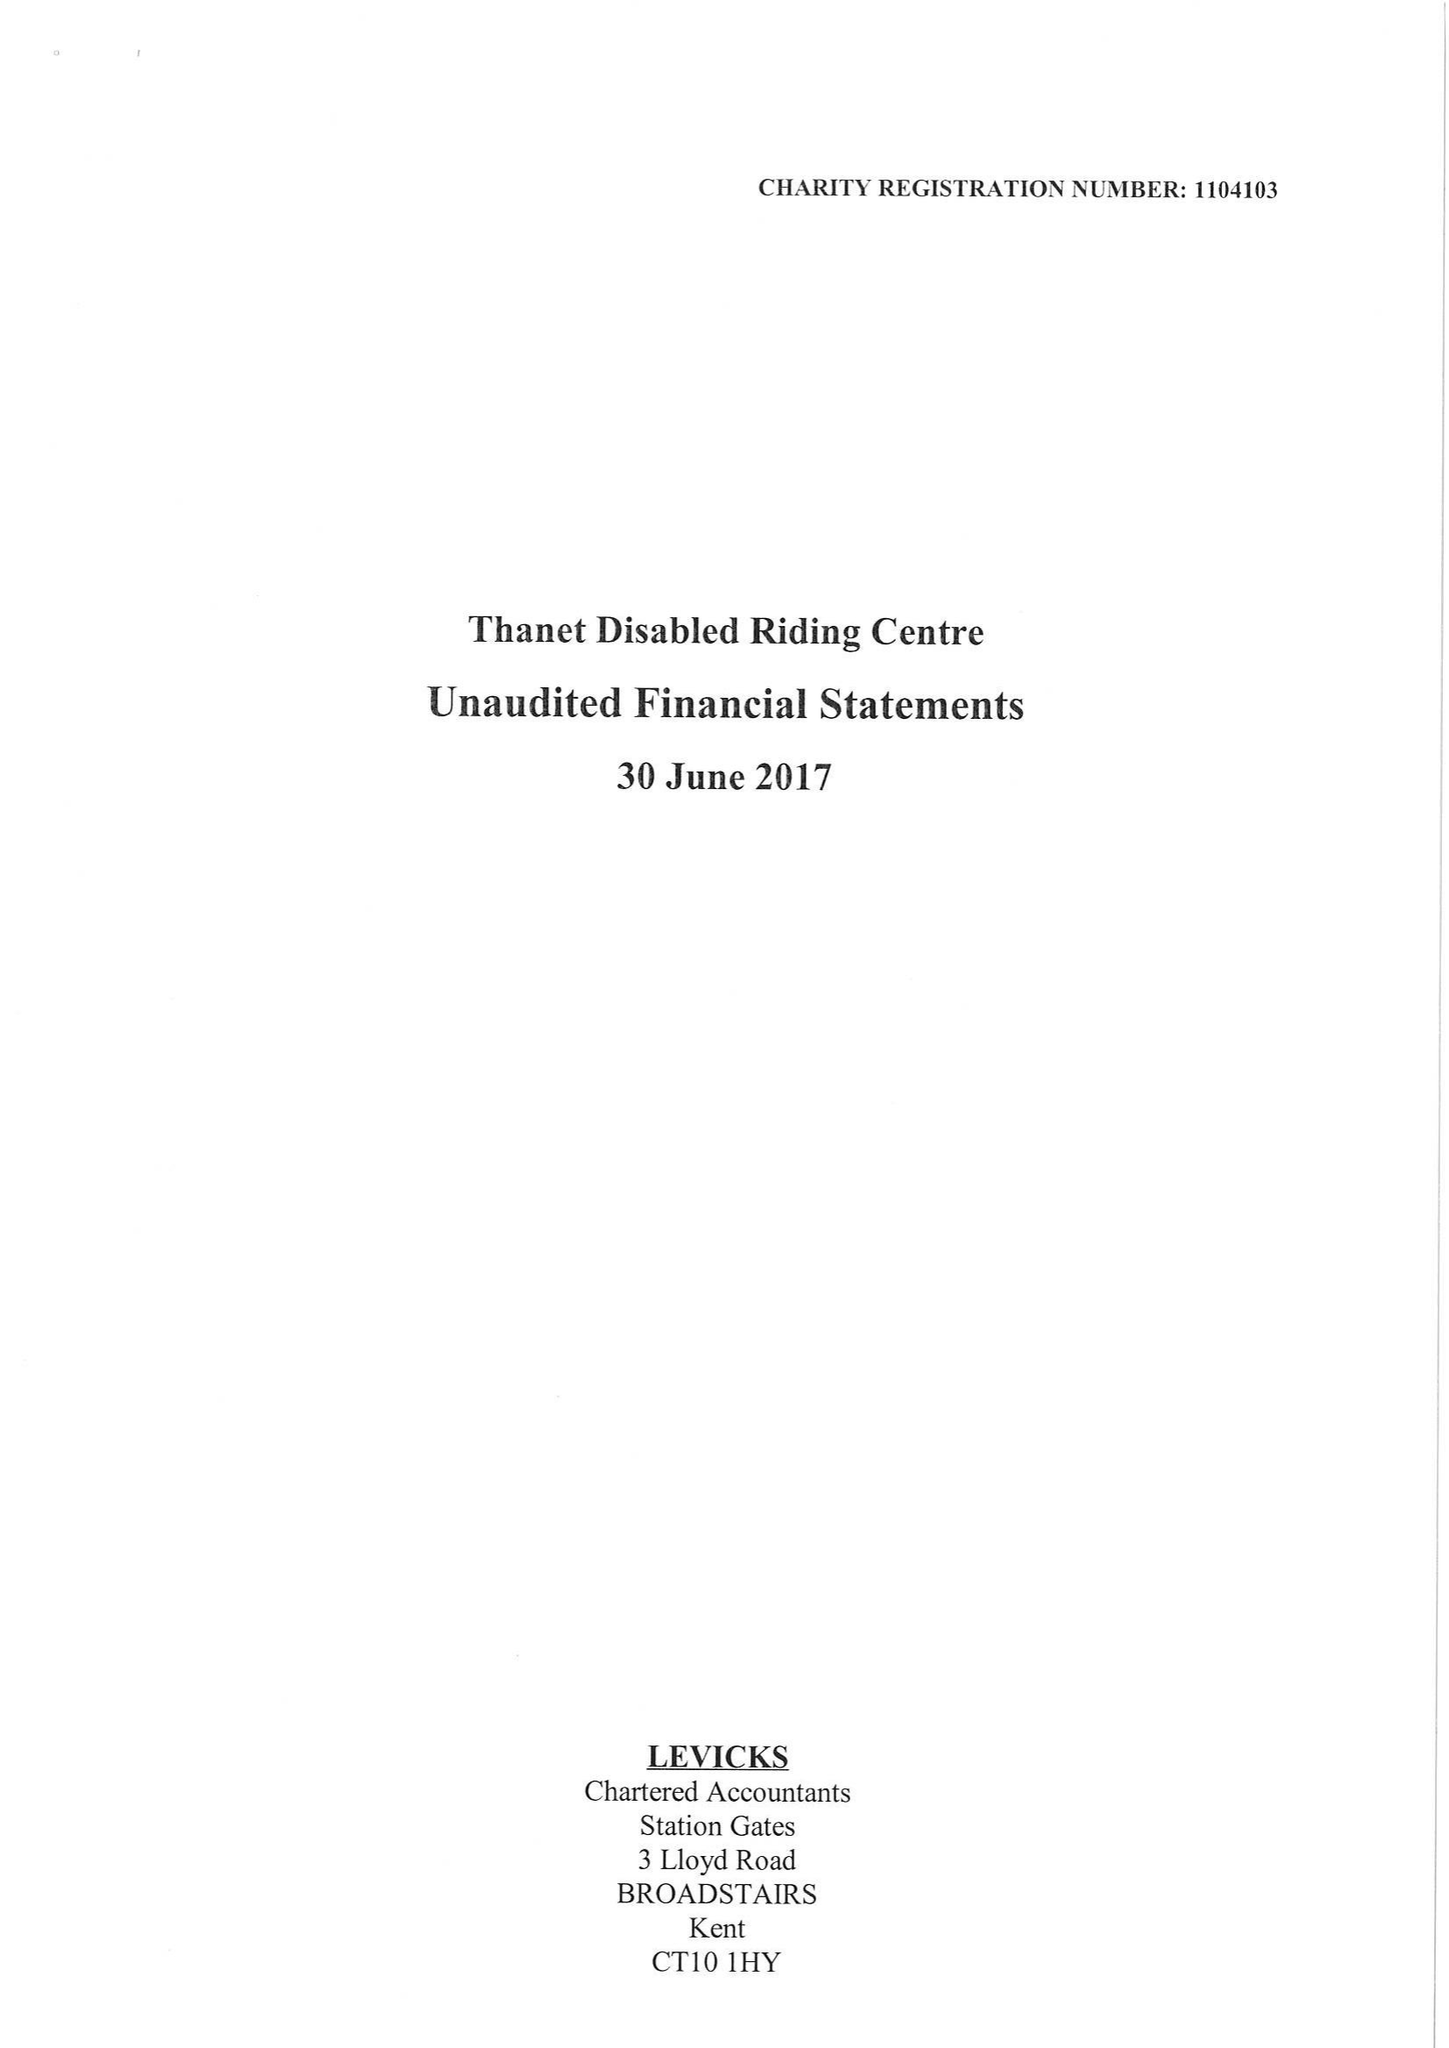What is the value for the spending_annually_in_british_pounds?
Answer the question using a single word or phrase. 45075.00 